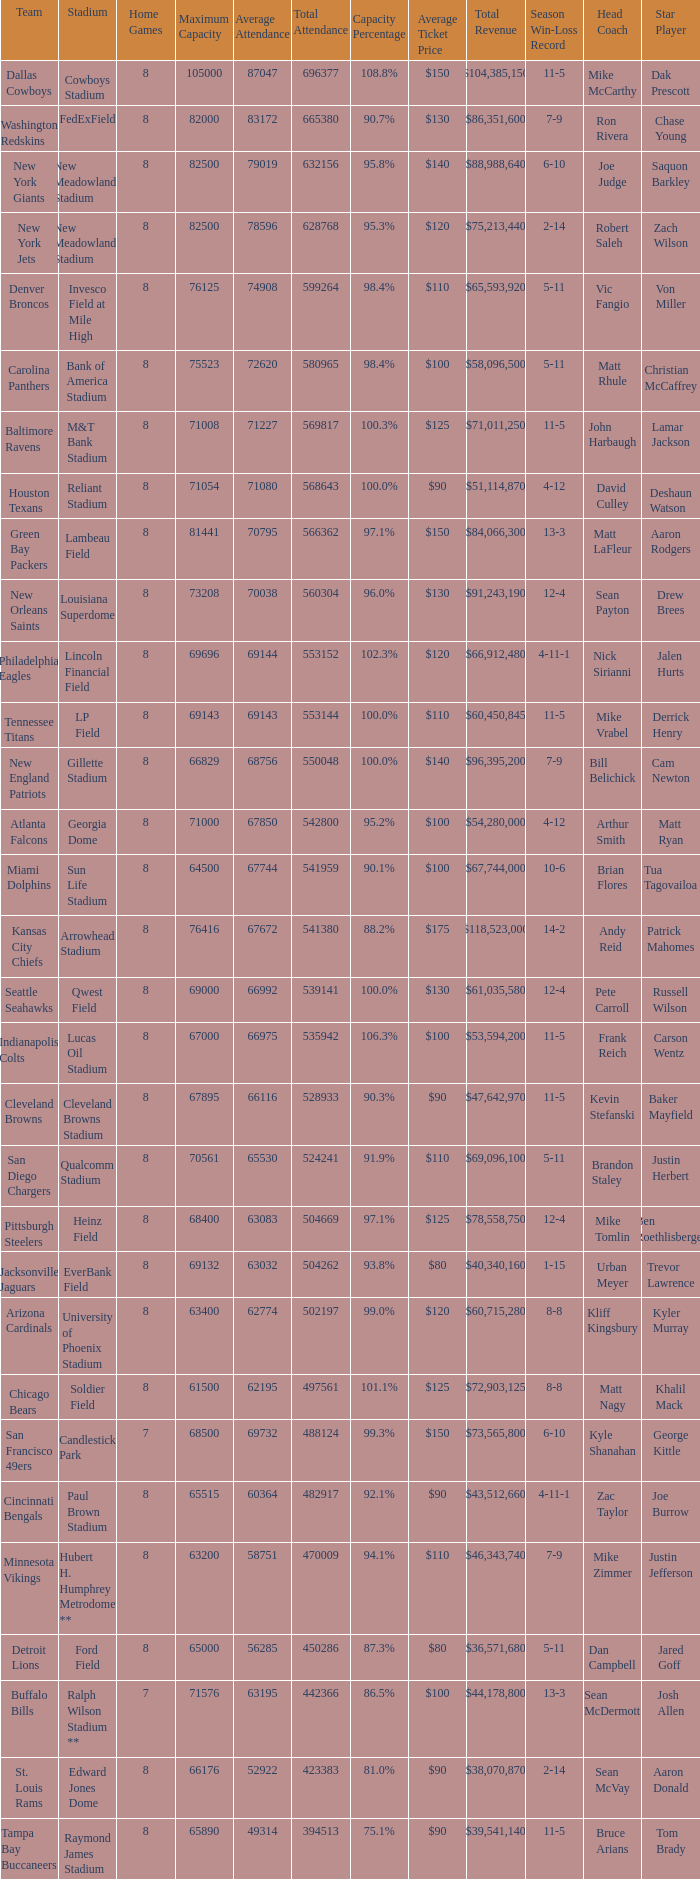What was the capacity for the Denver Broncos? 98.4%. 